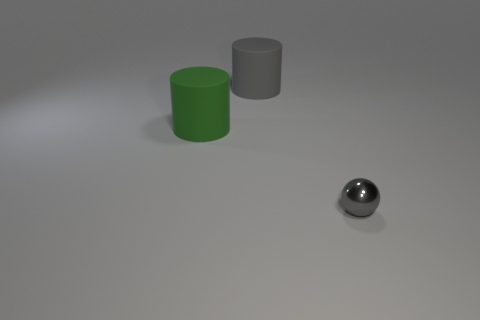Add 2 rubber cylinders. How many objects exist? 5 Subtract all cylinders. How many objects are left? 1 Subtract 0 cyan blocks. How many objects are left? 3 Subtract all blue cylinders. Subtract all large cylinders. How many objects are left? 1 Add 3 green objects. How many green objects are left? 4 Add 1 rubber things. How many rubber things exist? 3 